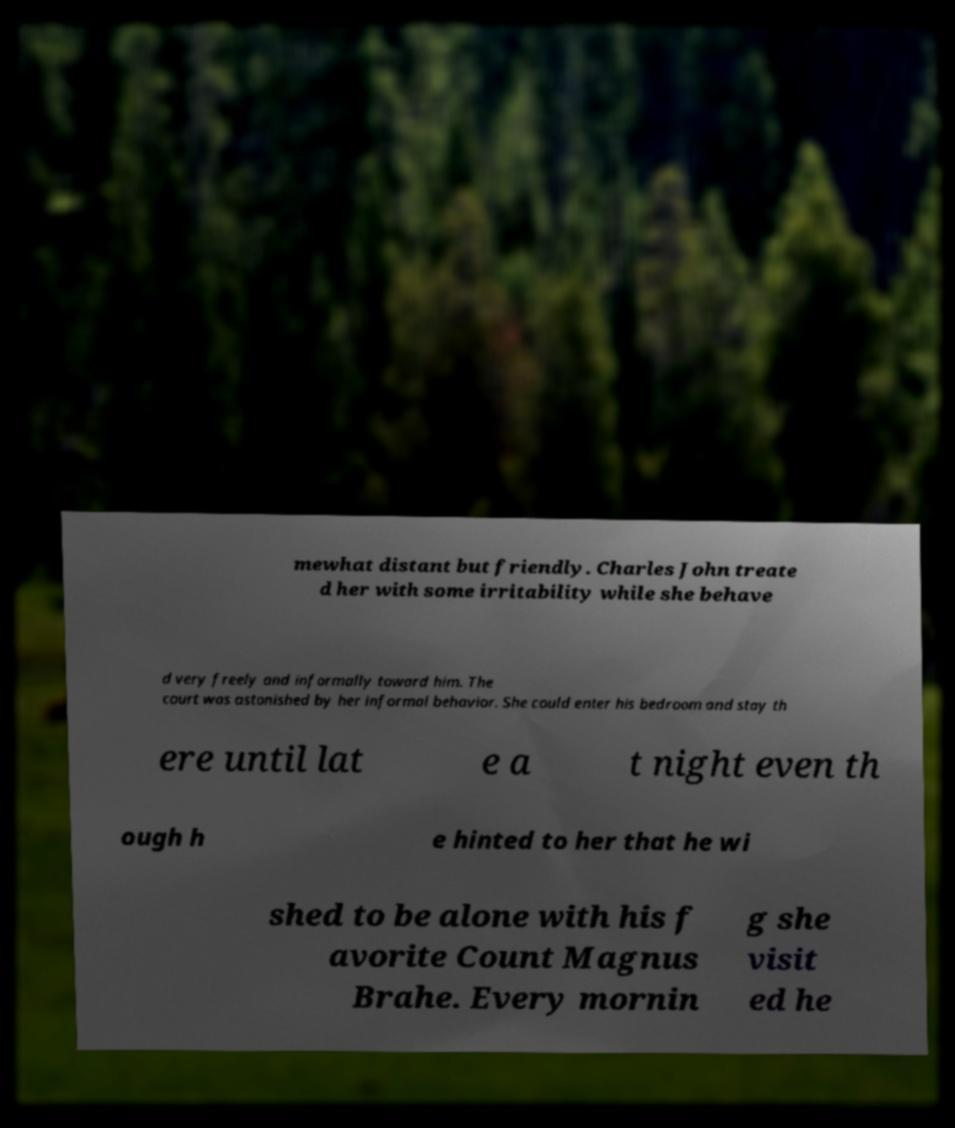For documentation purposes, I need the text within this image transcribed. Could you provide that? mewhat distant but friendly. Charles John treate d her with some irritability while she behave d very freely and informally toward him. The court was astonished by her informal behavior. She could enter his bedroom and stay th ere until lat e a t night even th ough h e hinted to her that he wi shed to be alone with his f avorite Count Magnus Brahe. Every mornin g she visit ed he 